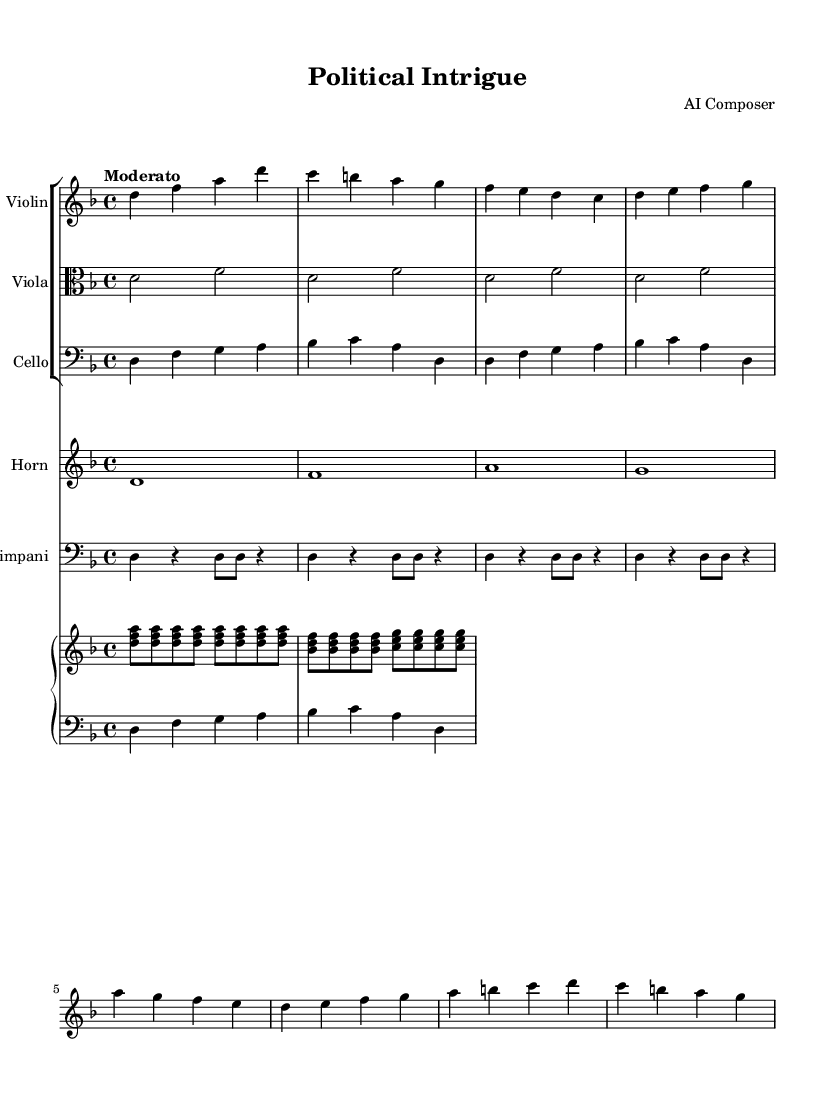What is the key signature of this music? The key signature is indicated next to the clef at the beginning of the staff. In this case, it shows one flat (B♭), which corresponds to the key of D minor.
Answer: D minor What is the time signature? The time signature appears at the beginning of the piece. Here, it is written as 4/4, indicating that there are four beats in each measure and the quarter note gets one beat.
Answer: 4/4 What is the tempo indication? The tempo indication is found near the start of the music, expressing the speed. In this score, it says "Moderato," which generally means a moderate tempo.
Answer: Moderato What is the instrumentation of this piece? The instrumentation can be determined by examining the labels at the beginning of each staff. The music is scored for Violin, Viola, Cello, Horn, Timpani, and Piano.
Answer: Violin, Viola, Cello, Horn, Timpani, Piano How many measures are in the cello part? By counting the groups of notes separated by the bar lines in the cello part, we can determine the number of measures. There are four measures present in the cello staff.
Answer: 4 What is the highest pitch used in the violin part? To find the highest pitch, we look at the notes in the violin staff. The notes are D, F, A, and the highest note shown is A, which is at the top of the violin's range in this score.
Answer: A Which instrument has the longest note value in this score? The longest note value can be identified by examining each instrument's part; in this case, the Horn section contains whole notes (1), which are the longest duration indicated in this score.
Answer: Horn 